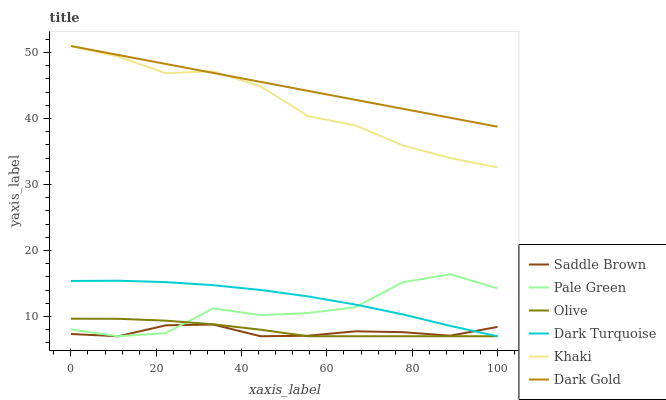Does Saddle Brown have the minimum area under the curve?
Answer yes or no. Yes. Does Dark Gold have the maximum area under the curve?
Answer yes or no. Yes. Does Dark Turquoise have the minimum area under the curve?
Answer yes or no. No. Does Dark Turquoise have the maximum area under the curve?
Answer yes or no. No. Is Dark Gold the smoothest?
Answer yes or no. Yes. Is Pale Green the roughest?
Answer yes or no. Yes. Is Dark Turquoise the smoothest?
Answer yes or no. No. Is Dark Turquoise the roughest?
Answer yes or no. No. Does Dark Gold have the lowest value?
Answer yes or no. No. Does Dark Gold have the highest value?
Answer yes or no. Yes. Does Dark Turquoise have the highest value?
Answer yes or no. No. Is Olive less than Dark Gold?
Answer yes or no. Yes. Is Khaki greater than Saddle Brown?
Answer yes or no. Yes. Does Dark Turquoise intersect Saddle Brown?
Answer yes or no. Yes. Is Dark Turquoise less than Saddle Brown?
Answer yes or no. No. Is Dark Turquoise greater than Saddle Brown?
Answer yes or no. No. Does Olive intersect Dark Gold?
Answer yes or no. No. 